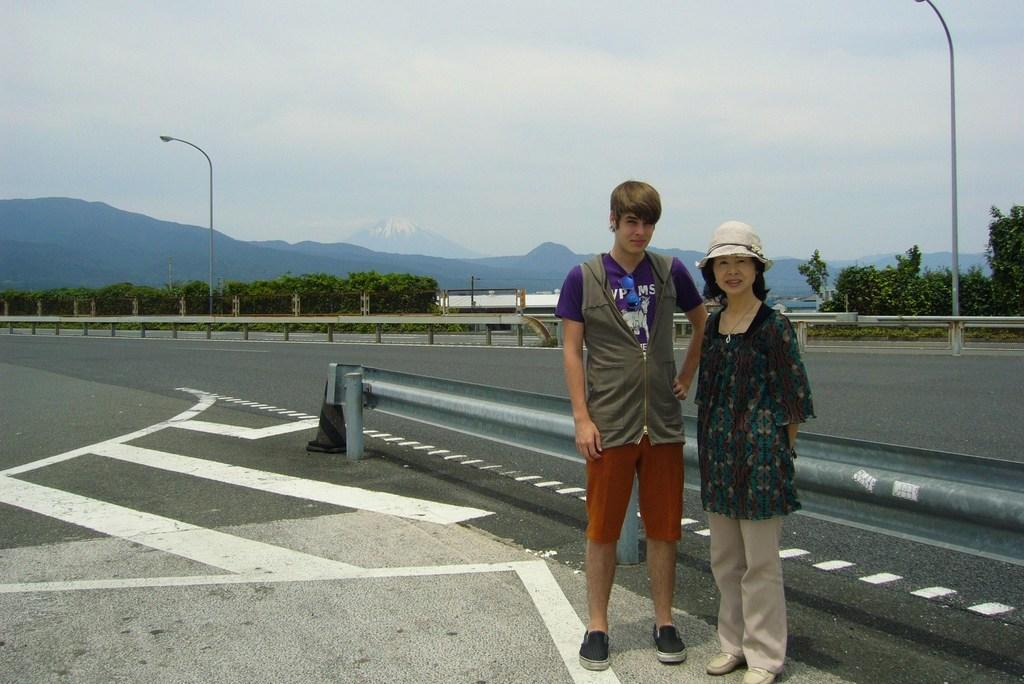How many people are present in the image? There are two people, a man and a woman, present in the image. Where are the man and woman located in the image? Both the man and woman are standing on a road in the image. What can be seen in the background of the image? There are poles, trees, mountains, and the sky visible in the background of the image. What type of card is the man holding in the image? There is no card present in the image; the man is not holding anything. 